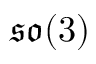<formula> <loc_0><loc_0><loc_500><loc_500>\mathfrak { s o } ( 3 )</formula> 